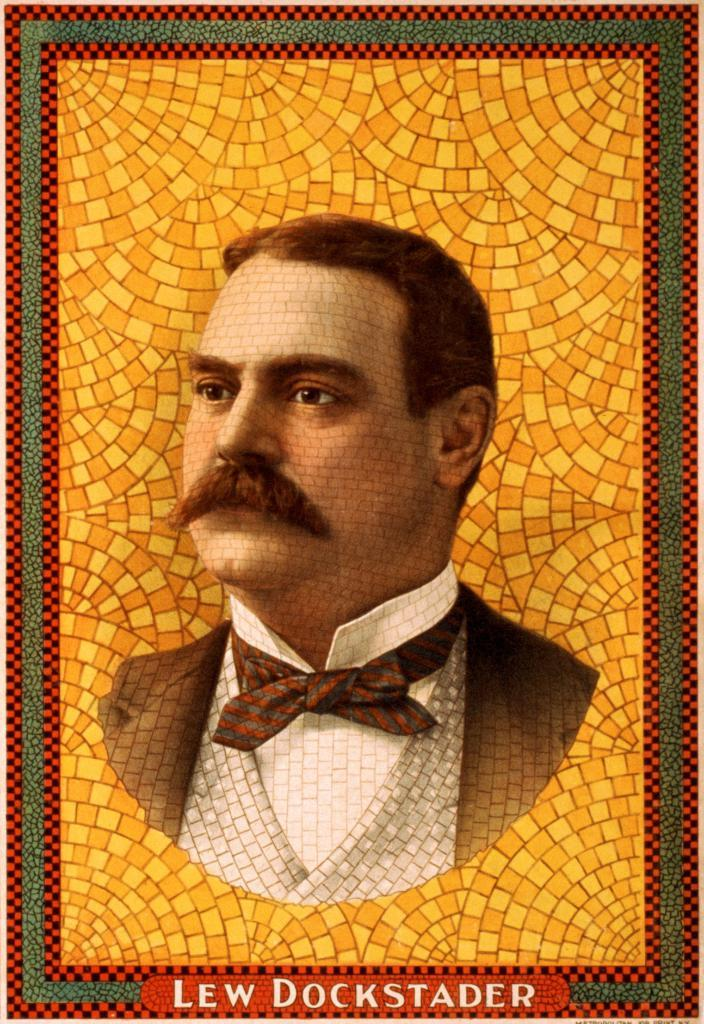What is the main subject of the image? There is a person with a mustache in the image. What color is the background of the image? The background of the image is yellow. What else can be seen in the image besides the person with a mustache? There is text written below the person. Can you tell me how many baseballs are on the roof in the image? There are no baseballs or roofs present in the image; it features a person with a mustache and yellow background with text. 